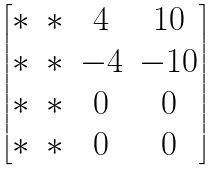<formula> <loc_0><loc_0><loc_500><loc_500>\begin{bmatrix} * & * & 4 & 1 0 \\ * & * & - 4 & - 1 0 \\ * & * & 0 & 0 \\ * & * & 0 & 0 \end{bmatrix}</formula> 